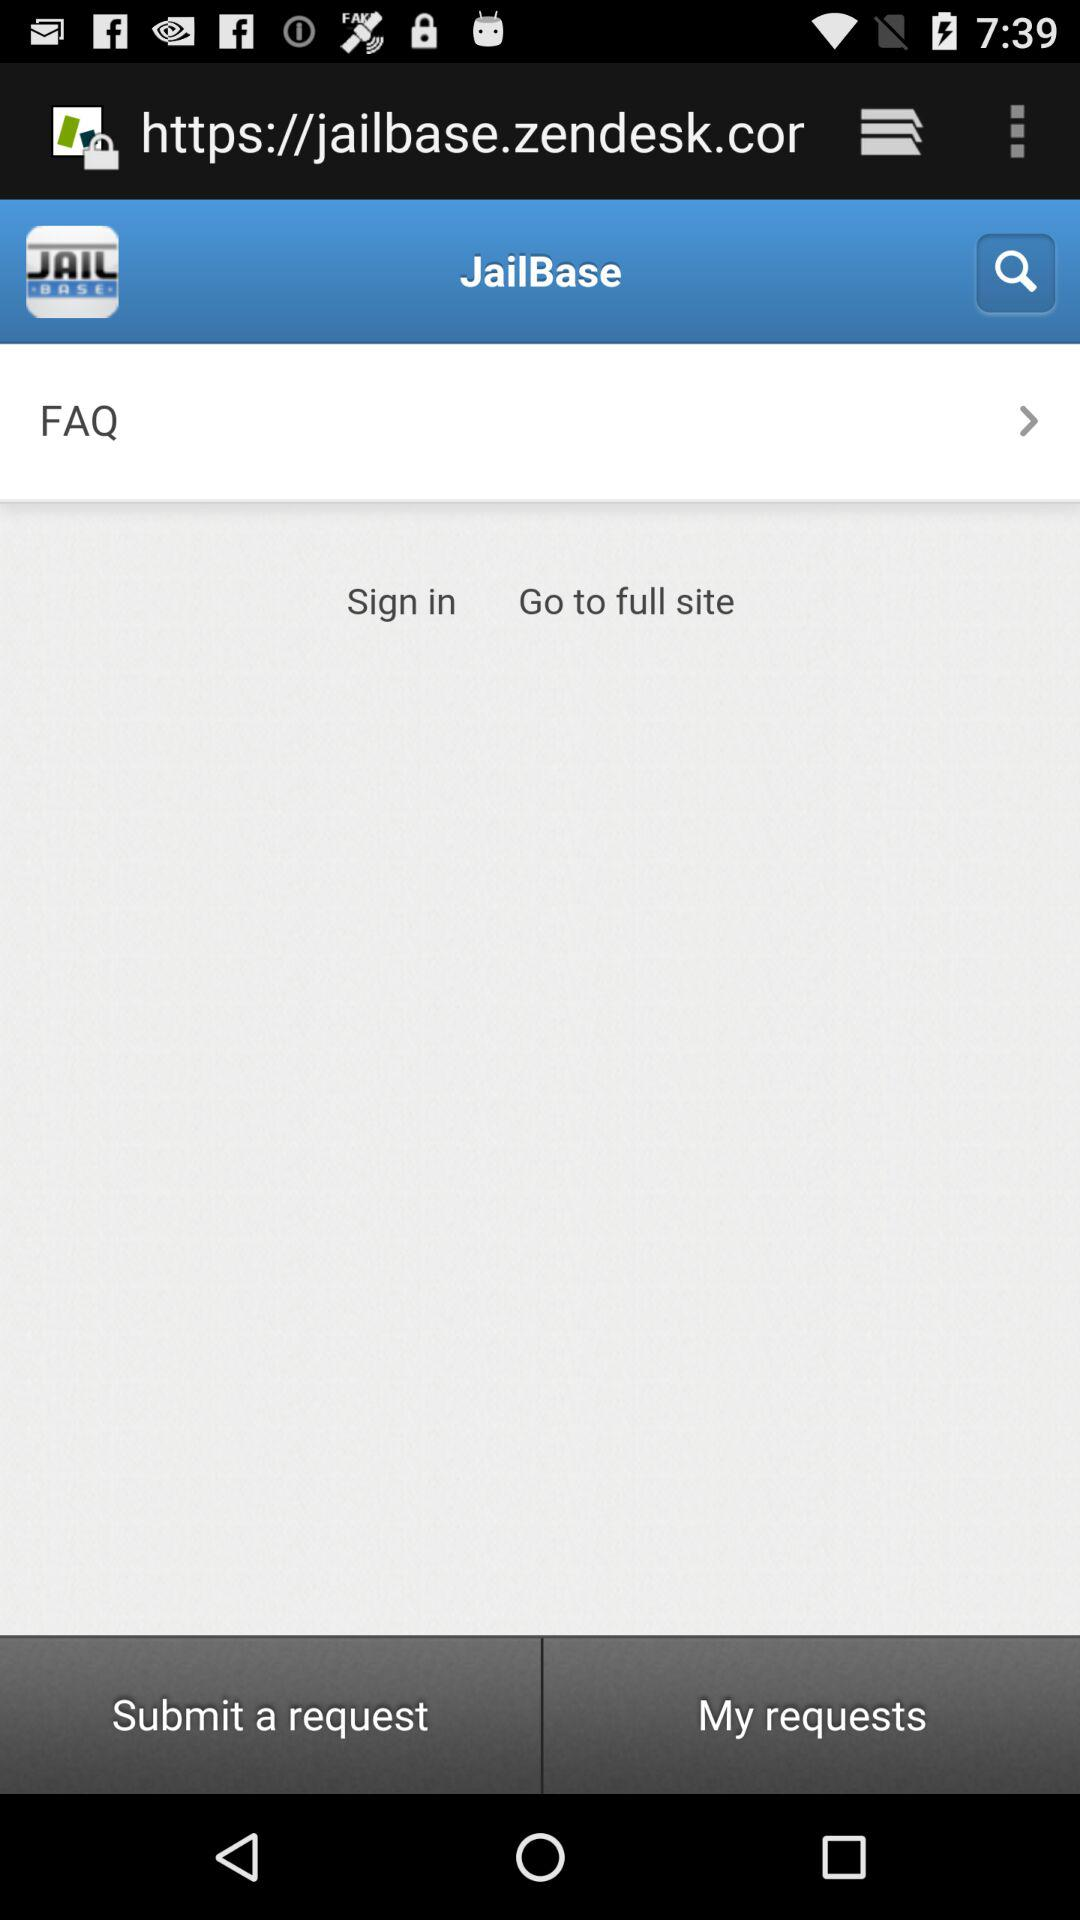What is the application name? The application name is "JailBase". 